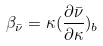<formula> <loc_0><loc_0><loc_500><loc_500>\beta _ { \bar { \nu } } = \kappa ( \frac { \partial \bar { \nu } } { \partial \kappa } ) _ { b }</formula> 